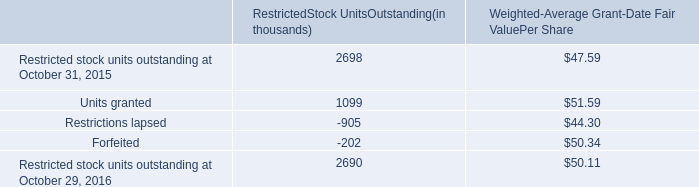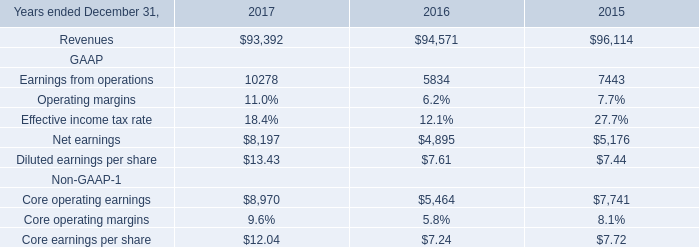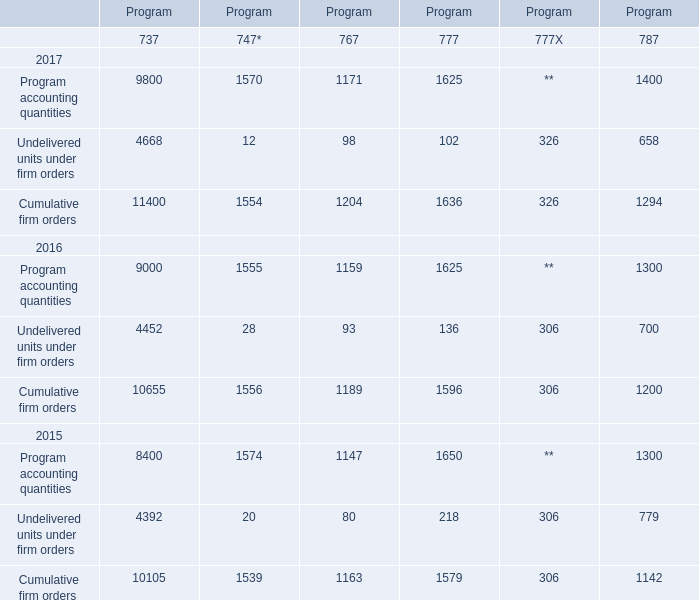What's the average of program accounting quantities of 737 and program accounting quantities of 767 in 2017? 
Computations: ((9800 + 1171) / 2)
Answer: 5485.5. What's the average of Net earnings GAAP of 2016, and Cumulative firm orders 2015 of Program.5 ? 
Computations: ((4895.0 + 1142.0) / 2)
Answer: 3018.5. 